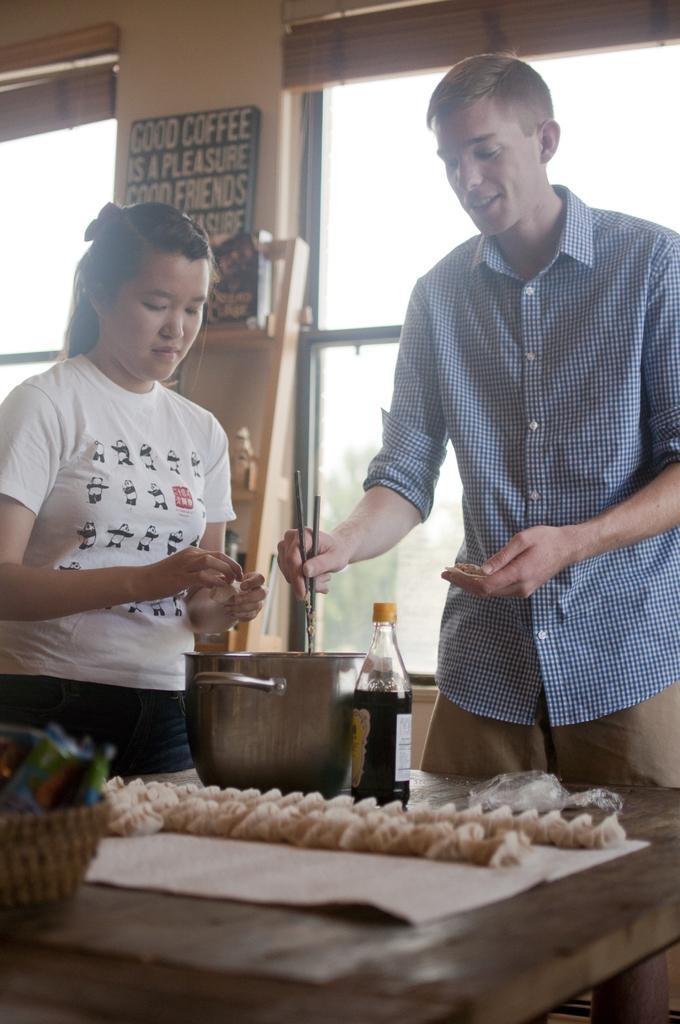Could you give a brief overview of what you see in this image? In this image i can see a woman and a man standing, man doing some work in a bowl there a bottle and food on a table at the back ground i can see a board, a wall and a window. 